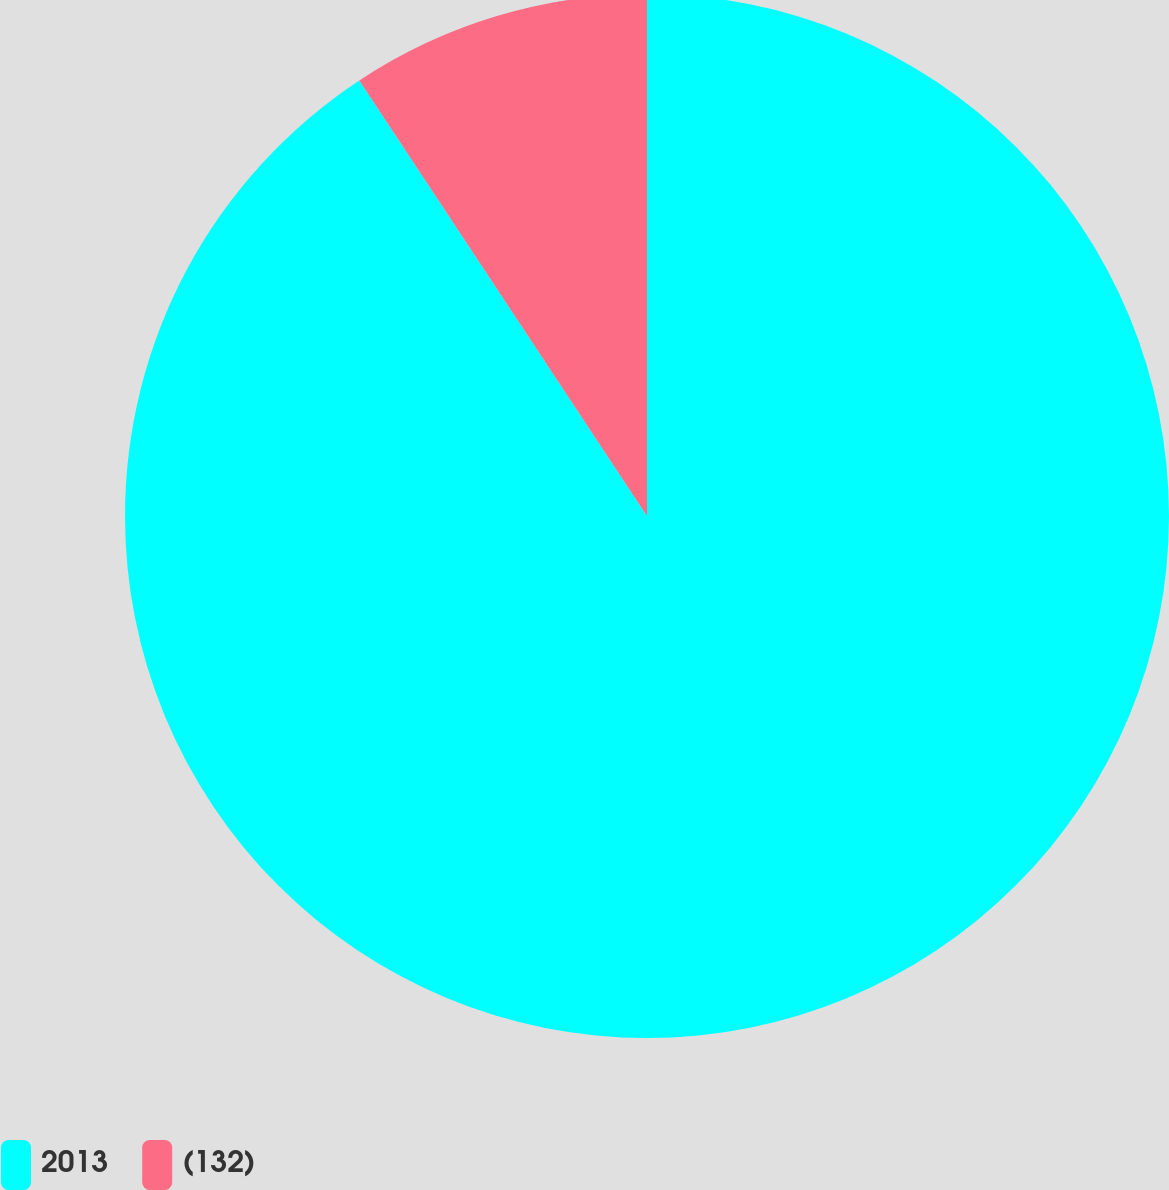Convert chart. <chart><loc_0><loc_0><loc_500><loc_500><pie_chart><fcel>2013<fcel>(132)<nl><fcel>90.71%<fcel>9.29%<nl></chart> 